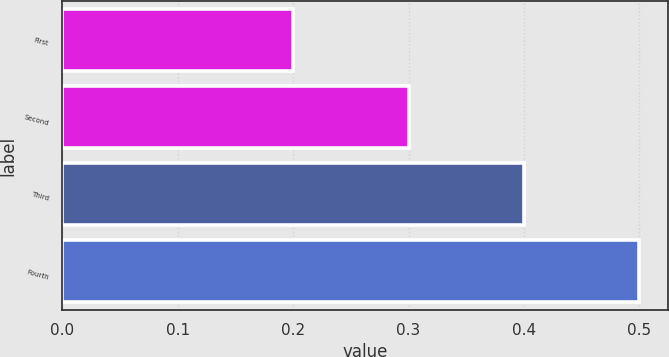Convert chart to OTSL. <chart><loc_0><loc_0><loc_500><loc_500><bar_chart><fcel>First<fcel>Second<fcel>Third<fcel>Fourth<nl><fcel>0.2<fcel>0.3<fcel>0.4<fcel>0.5<nl></chart> 